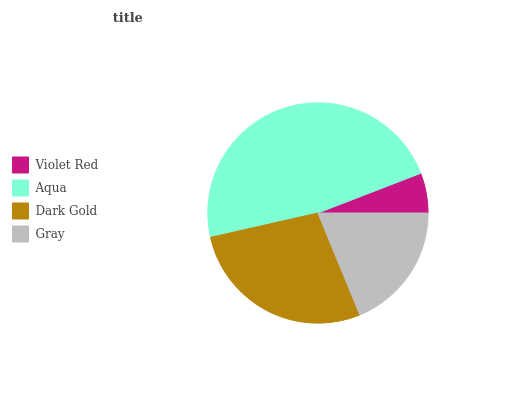Is Violet Red the minimum?
Answer yes or no. Yes. Is Aqua the maximum?
Answer yes or no. Yes. Is Dark Gold the minimum?
Answer yes or no. No. Is Dark Gold the maximum?
Answer yes or no. No. Is Aqua greater than Dark Gold?
Answer yes or no. Yes. Is Dark Gold less than Aqua?
Answer yes or no. Yes. Is Dark Gold greater than Aqua?
Answer yes or no. No. Is Aqua less than Dark Gold?
Answer yes or no. No. Is Dark Gold the high median?
Answer yes or no. Yes. Is Gray the low median?
Answer yes or no. Yes. Is Aqua the high median?
Answer yes or no. No. Is Aqua the low median?
Answer yes or no. No. 